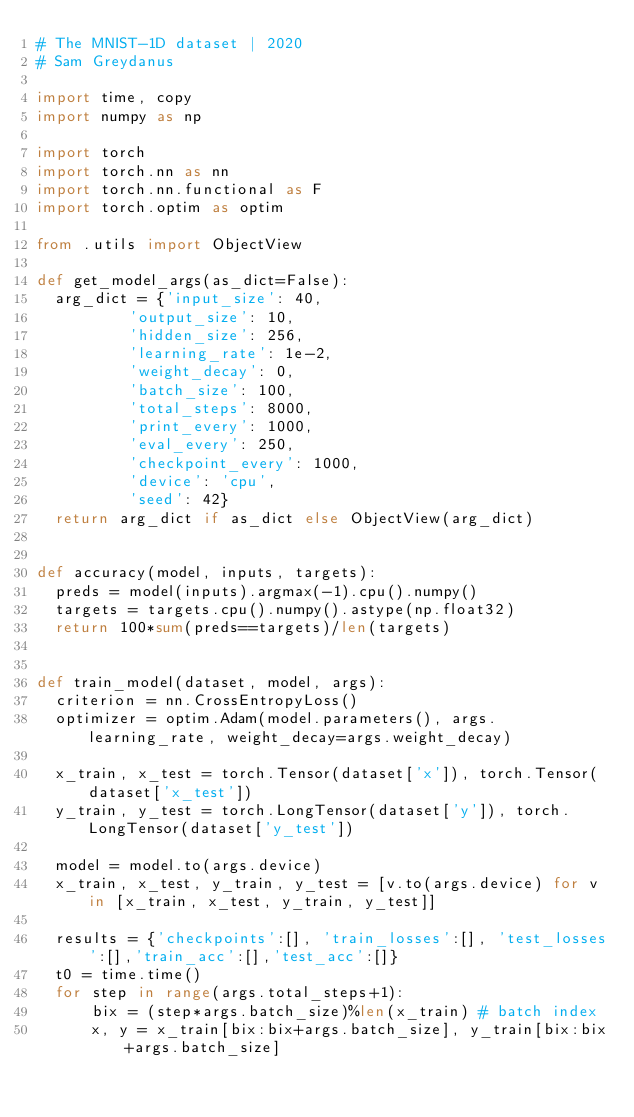Convert code to text. <code><loc_0><loc_0><loc_500><loc_500><_Python_># The MNIST-1D dataset | 2020
# Sam Greydanus

import time, copy
import numpy as np

import torch
import torch.nn as nn
import torch.nn.functional as F
import torch.optim as optim

from .utils import ObjectView

def get_model_args(as_dict=False):
  arg_dict = {'input_size': 40,
          'output_size': 10,
          'hidden_size': 256,
          'learning_rate': 1e-2,
          'weight_decay': 0,
          'batch_size': 100,
          'total_steps': 8000,
          'print_every': 1000,
          'eval_every': 250,
          'checkpoint_every': 1000,
          'device': 'cpu',
          'seed': 42}
  return arg_dict if as_dict else ObjectView(arg_dict)


def accuracy(model, inputs, targets):
  preds = model(inputs).argmax(-1).cpu().numpy()
  targets = targets.cpu().numpy().astype(np.float32)
  return 100*sum(preds==targets)/len(targets)


def train_model(dataset, model, args):
  criterion = nn.CrossEntropyLoss()
  optimizer = optim.Adam(model.parameters(), args.learning_rate, weight_decay=args.weight_decay)

  x_train, x_test = torch.Tensor(dataset['x']), torch.Tensor(dataset['x_test'])
  y_train, y_test = torch.LongTensor(dataset['y']), torch.LongTensor(dataset['y_test'])

  model = model.to(args.device)
  x_train, x_test, y_train, y_test = [v.to(args.device) for v in [x_train, x_test, y_train, y_test]]

  results = {'checkpoints':[], 'train_losses':[], 'test_losses':[],'train_acc':[],'test_acc':[]}
  t0 = time.time()
  for step in range(args.total_steps+1):
      bix = (step*args.batch_size)%len(x_train) # batch index
      x, y = x_train[bix:bix+args.batch_size], y_train[bix:bix+args.batch_size]</code> 